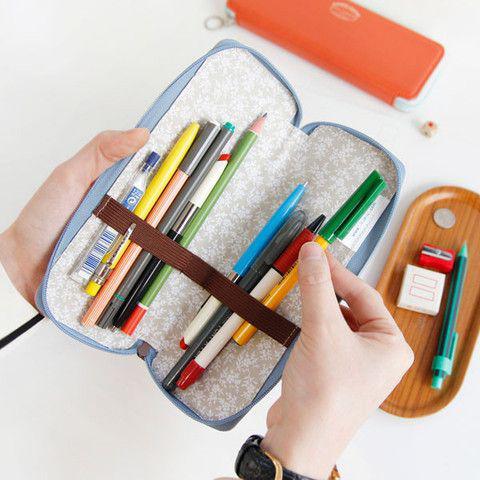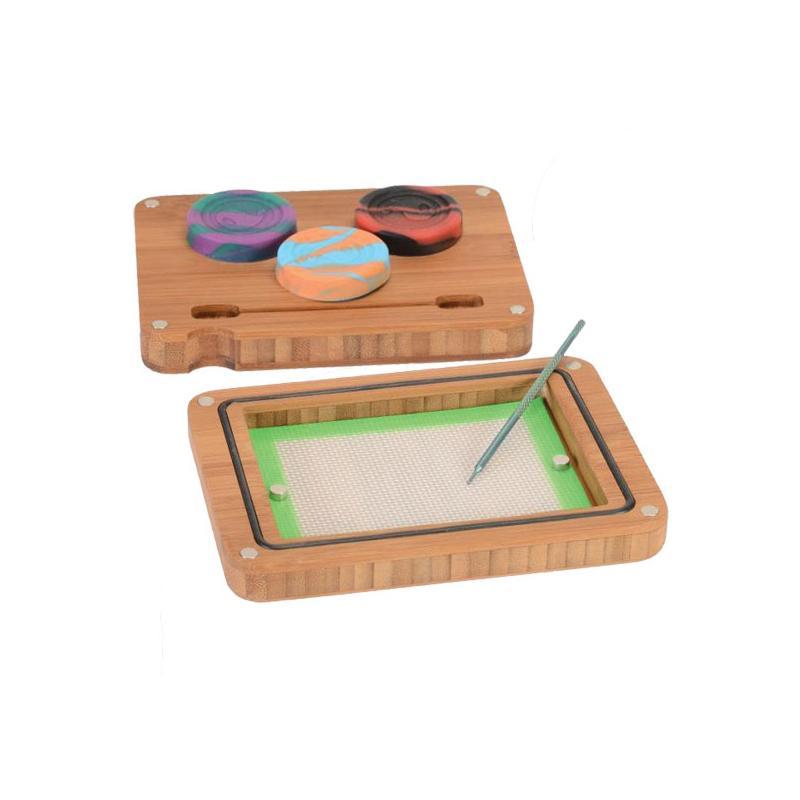The first image is the image on the left, the second image is the image on the right. Considering the images on both sides, is "The left image shows a pair of hands holding a zipper case featuring light-blue color and its contents." valid? Answer yes or no. Yes. The first image is the image on the left, the second image is the image on the right. Considering the images on both sides, is "One of the images features someone holding a pencil case." valid? Answer yes or no. Yes. 